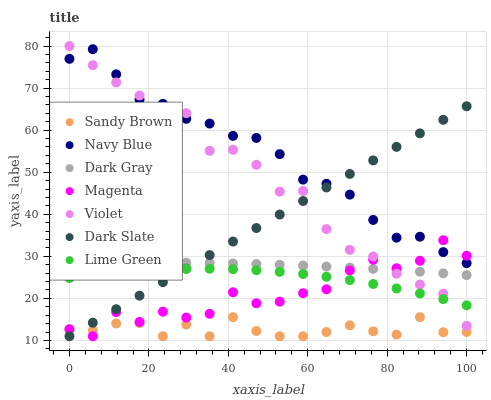Does Sandy Brown have the minimum area under the curve?
Answer yes or no. Yes. Does Navy Blue have the maximum area under the curve?
Answer yes or no. Yes. Does Lime Green have the minimum area under the curve?
Answer yes or no. No. Does Lime Green have the maximum area under the curve?
Answer yes or no. No. Is Dark Slate the smoothest?
Answer yes or no. Yes. Is Magenta the roughest?
Answer yes or no. Yes. Is Lime Green the smoothest?
Answer yes or no. No. Is Lime Green the roughest?
Answer yes or no. No. Does Dark Slate have the lowest value?
Answer yes or no. Yes. Does Lime Green have the lowest value?
Answer yes or no. No. Does Violet have the highest value?
Answer yes or no. Yes. Does Lime Green have the highest value?
Answer yes or no. No. Is Lime Green less than Navy Blue?
Answer yes or no. Yes. Is Navy Blue greater than Dark Gray?
Answer yes or no. Yes. Does Dark Slate intersect Violet?
Answer yes or no. Yes. Is Dark Slate less than Violet?
Answer yes or no. No. Is Dark Slate greater than Violet?
Answer yes or no. No. Does Lime Green intersect Navy Blue?
Answer yes or no. No. 